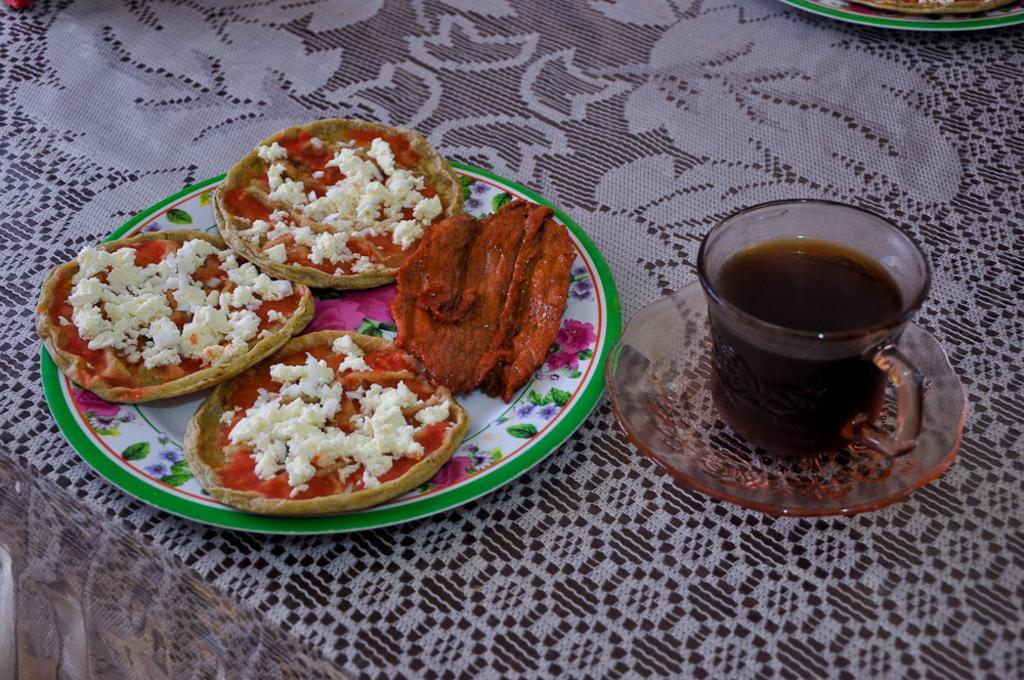Could you give a brief overview of what you see in this image? In this picture we can see table and on table we have cloth, plate full of food, cup with drink in it, saucer. 